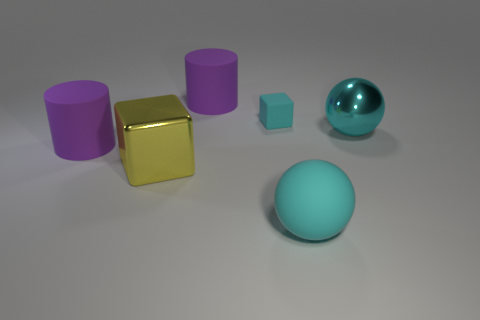Is the number of purple cylinders greater than the number of yellow blocks?
Your answer should be compact. Yes. The matte cylinder behind the big shiny thing on the right side of the cyan matte thing that is on the right side of the cyan matte block is what color?
Your answer should be compact. Purple. There is a big rubber object behind the large shiny ball; does it have the same shape as the small cyan matte object?
Provide a succinct answer. No. What color is the matte ball that is the same size as the cyan metallic ball?
Ensure brevity in your answer.  Cyan. How many large blue metal cylinders are there?
Keep it short and to the point. 0. Are the thing left of the yellow cube and the small cyan thing made of the same material?
Provide a short and direct response. Yes. There is a cyan thing that is behind the rubber ball and in front of the cyan matte block; what material is it made of?
Your answer should be compact. Metal. There is a cube that is the same color as the large metallic sphere; what is its size?
Offer a very short reply. Small. The cylinder to the left of the cylinder that is behind the tiny cube is made of what material?
Offer a terse response. Rubber. There is a block that is behind the purple thing in front of the matte cylinder on the right side of the big block; what is its size?
Ensure brevity in your answer.  Small. 